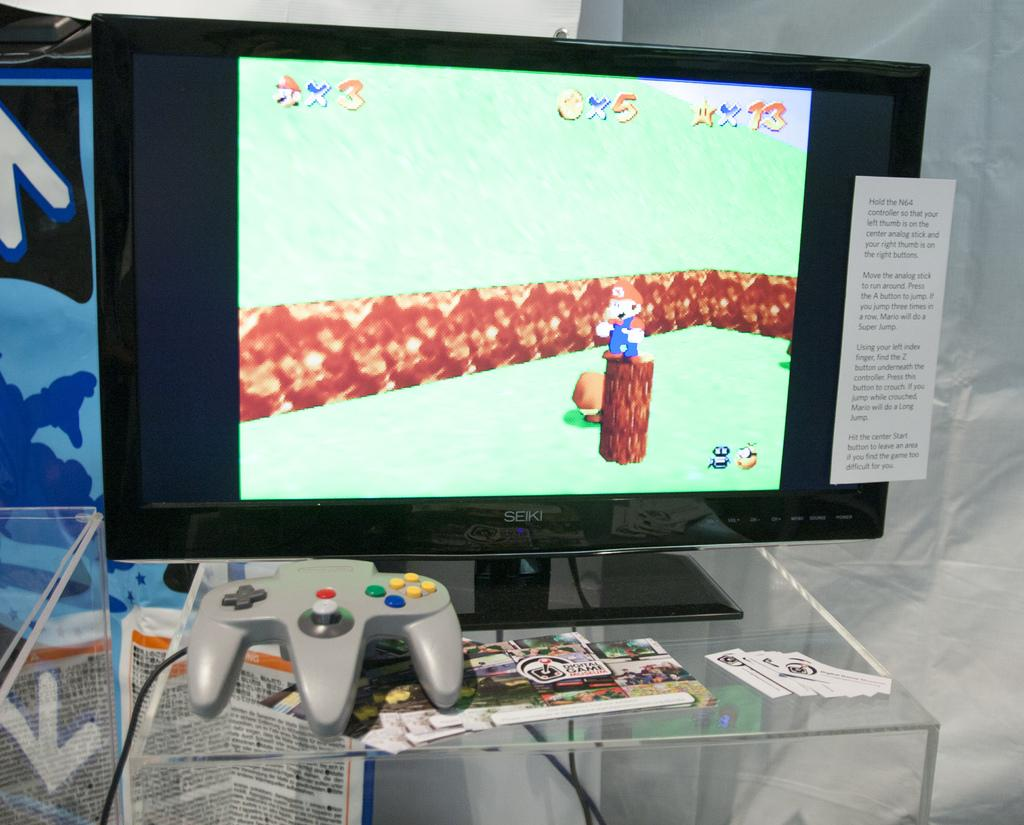<image>
Relay a brief, clear account of the picture shown. Computer screen showing that the character only has 3 lives. 